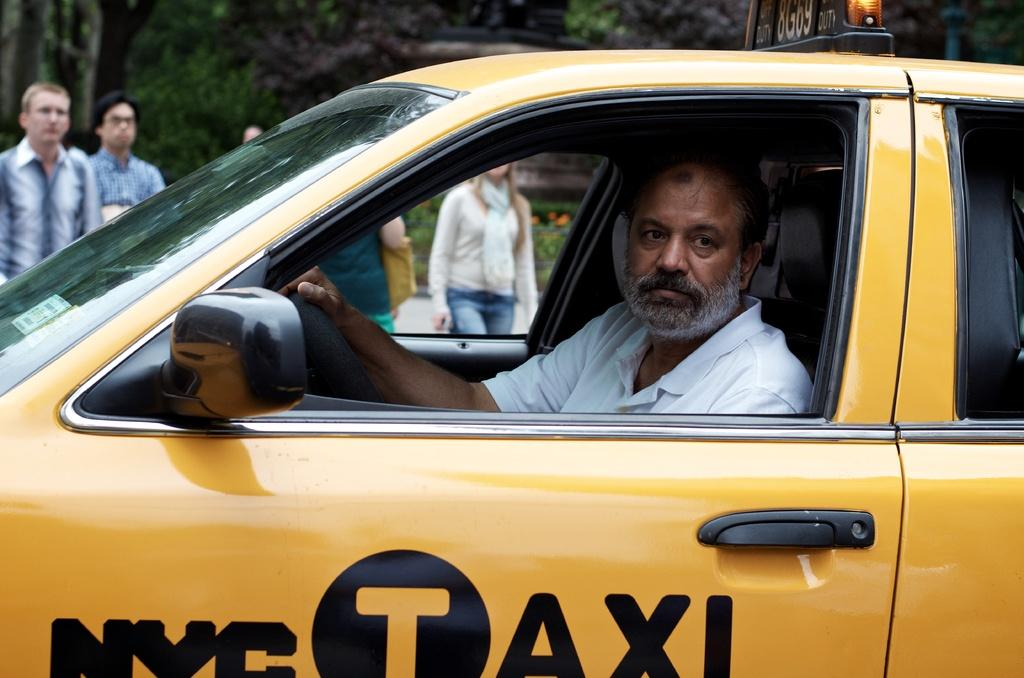<image>
Give a short and clear explanation of the subsequent image. A man is driving a yellow NYC Taxi. 